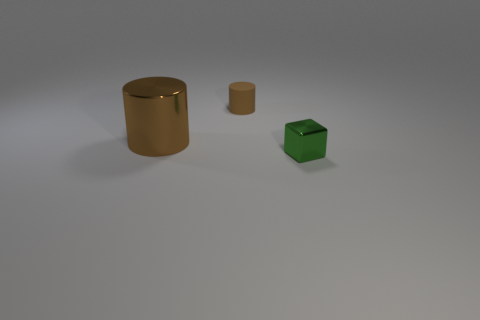Add 3 matte cylinders. How many objects exist? 6 Subtract all cubes. How many objects are left? 2 Subtract 0 purple cylinders. How many objects are left? 3 Subtract all brown cylinders. Subtract all shiny blocks. How many objects are left? 0 Add 3 brown things. How many brown things are left? 5 Add 1 metal cylinders. How many metal cylinders exist? 2 